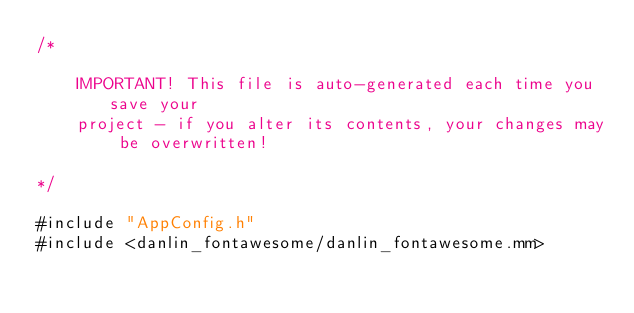Convert code to text. <code><loc_0><loc_0><loc_500><loc_500><_ObjectiveC_>/*

    IMPORTANT! This file is auto-generated each time you save your
    project - if you alter its contents, your changes may be overwritten!

*/

#include "AppConfig.h"
#include <danlin_fontawesome/danlin_fontawesome.mm>
</code> 